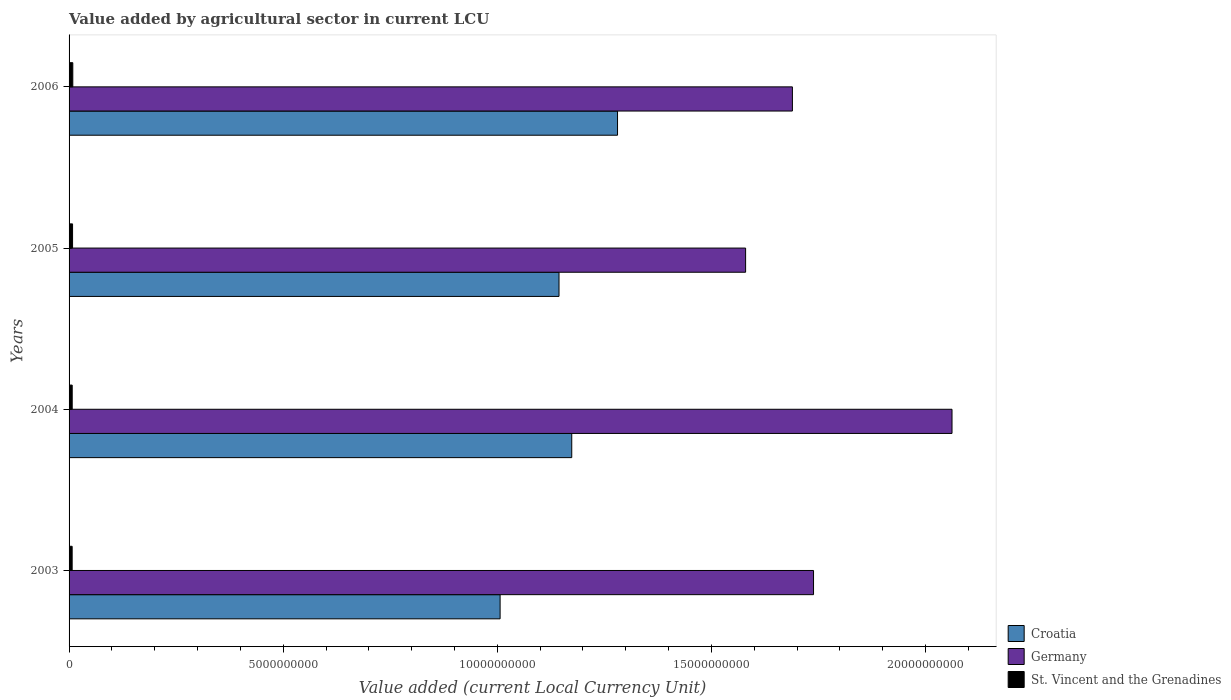How many different coloured bars are there?
Offer a terse response. 3. How many groups of bars are there?
Keep it short and to the point. 4. Are the number of bars on each tick of the Y-axis equal?
Offer a very short reply. Yes. How many bars are there on the 4th tick from the top?
Provide a succinct answer. 3. How many bars are there on the 2nd tick from the bottom?
Make the answer very short. 3. What is the label of the 4th group of bars from the top?
Offer a terse response. 2003. In how many cases, is the number of bars for a given year not equal to the number of legend labels?
Give a very brief answer. 0. What is the value added by agricultural sector in Croatia in 2004?
Keep it short and to the point. 1.17e+1. Across all years, what is the maximum value added by agricultural sector in Germany?
Offer a very short reply. 2.06e+1. Across all years, what is the minimum value added by agricultural sector in Croatia?
Make the answer very short. 1.01e+1. What is the total value added by agricultural sector in Croatia in the graph?
Offer a very short reply. 4.61e+1. What is the difference between the value added by agricultural sector in Croatia in 2003 and that in 2006?
Give a very brief answer. -2.74e+09. What is the difference between the value added by agricultural sector in St. Vincent and the Grenadines in 2004 and the value added by agricultural sector in Croatia in 2003?
Keep it short and to the point. -9.99e+09. What is the average value added by agricultural sector in Germany per year?
Your answer should be compact. 1.77e+1. In the year 2004, what is the difference between the value added by agricultural sector in Croatia and value added by agricultural sector in St. Vincent and the Grenadines?
Keep it short and to the point. 1.17e+1. What is the ratio of the value added by agricultural sector in Germany in 2003 to that in 2004?
Keep it short and to the point. 0.84. Is the value added by agricultural sector in Germany in 2003 less than that in 2005?
Offer a terse response. No. What is the difference between the highest and the second highest value added by agricultural sector in St. Vincent and the Grenadines?
Your answer should be compact. 5.52e+06. What is the difference between the highest and the lowest value added by agricultural sector in Croatia?
Offer a very short reply. 2.74e+09. What does the 3rd bar from the bottom in 2003 represents?
Provide a succinct answer. St. Vincent and the Grenadines. How many bars are there?
Your answer should be compact. 12. How many years are there in the graph?
Provide a short and direct response. 4. Does the graph contain any zero values?
Make the answer very short. No. Does the graph contain grids?
Your answer should be very brief. No. How are the legend labels stacked?
Provide a succinct answer. Vertical. What is the title of the graph?
Provide a succinct answer. Value added by agricultural sector in current LCU. What is the label or title of the X-axis?
Provide a succinct answer. Value added (current Local Currency Unit). What is the Value added (current Local Currency Unit) of Croatia in 2003?
Offer a very short reply. 1.01e+1. What is the Value added (current Local Currency Unit) of Germany in 2003?
Ensure brevity in your answer.  1.74e+1. What is the Value added (current Local Currency Unit) in St. Vincent and the Grenadines in 2003?
Ensure brevity in your answer.  7.19e+07. What is the Value added (current Local Currency Unit) in Croatia in 2004?
Make the answer very short. 1.17e+1. What is the Value added (current Local Currency Unit) of Germany in 2004?
Offer a terse response. 2.06e+1. What is the Value added (current Local Currency Unit) of St. Vincent and the Grenadines in 2004?
Your answer should be very brief. 7.33e+07. What is the Value added (current Local Currency Unit) of Croatia in 2005?
Provide a succinct answer. 1.14e+1. What is the Value added (current Local Currency Unit) in Germany in 2005?
Provide a short and direct response. 1.58e+1. What is the Value added (current Local Currency Unit) in St. Vincent and the Grenadines in 2005?
Provide a short and direct response. 8.14e+07. What is the Value added (current Local Currency Unit) in Croatia in 2006?
Keep it short and to the point. 1.28e+1. What is the Value added (current Local Currency Unit) of Germany in 2006?
Offer a terse response. 1.69e+1. What is the Value added (current Local Currency Unit) of St. Vincent and the Grenadines in 2006?
Provide a short and direct response. 8.69e+07. Across all years, what is the maximum Value added (current Local Currency Unit) of Croatia?
Make the answer very short. 1.28e+1. Across all years, what is the maximum Value added (current Local Currency Unit) of Germany?
Your answer should be very brief. 2.06e+1. Across all years, what is the maximum Value added (current Local Currency Unit) of St. Vincent and the Grenadines?
Provide a succinct answer. 8.69e+07. Across all years, what is the minimum Value added (current Local Currency Unit) in Croatia?
Your answer should be compact. 1.01e+1. Across all years, what is the minimum Value added (current Local Currency Unit) in Germany?
Provide a short and direct response. 1.58e+1. Across all years, what is the minimum Value added (current Local Currency Unit) in St. Vincent and the Grenadines?
Make the answer very short. 7.19e+07. What is the total Value added (current Local Currency Unit) in Croatia in the graph?
Offer a very short reply. 4.61e+1. What is the total Value added (current Local Currency Unit) in Germany in the graph?
Your response must be concise. 7.07e+1. What is the total Value added (current Local Currency Unit) in St. Vincent and the Grenadines in the graph?
Provide a short and direct response. 3.14e+08. What is the difference between the Value added (current Local Currency Unit) in Croatia in 2003 and that in 2004?
Keep it short and to the point. -1.67e+09. What is the difference between the Value added (current Local Currency Unit) in Germany in 2003 and that in 2004?
Ensure brevity in your answer.  -3.23e+09. What is the difference between the Value added (current Local Currency Unit) of St. Vincent and the Grenadines in 2003 and that in 2004?
Offer a terse response. -1.41e+06. What is the difference between the Value added (current Local Currency Unit) of Croatia in 2003 and that in 2005?
Give a very brief answer. -1.38e+09. What is the difference between the Value added (current Local Currency Unit) of Germany in 2003 and that in 2005?
Keep it short and to the point. 1.59e+09. What is the difference between the Value added (current Local Currency Unit) of St. Vincent and the Grenadines in 2003 and that in 2005?
Provide a short and direct response. -9.50e+06. What is the difference between the Value added (current Local Currency Unit) of Croatia in 2003 and that in 2006?
Provide a succinct answer. -2.74e+09. What is the difference between the Value added (current Local Currency Unit) in Germany in 2003 and that in 2006?
Provide a succinct answer. 4.93e+08. What is the difference between the Value added (current Local Currency Unit) of St. Vincent and the Grenadines in 2003 and that in 2006?
Your answer should be compact. -1.50e+07. What is the difference between the Value added (current Local Currency Unit) in Croatia in 2004 and that in 2005?
Your answer should be very brief. 2.97e+08. What is the difference between the Value added (current Local Currency Unit) of Germany in 2004 and that in 2005?
Keep it short and to the point. 4.82e+09. What is the difference between the Value added (current Local Currency Unit) of St. Vincent and the Grenadines in 2004 and that in 2005?
Your answer should be compact. -8.09e+06. What is the difference between the Value added (current Local Currency Unit) in Croatia in 2004 and that in 2006?
Provide a succinct answer. -1.07e+09. What is the difference between the Value added (current Local Currency Unit) of Germany in 2004 and that in 2006?
Ensure brevity in your answer.  3.73e+09. What is the difference between the Value added (current Local Currency Unit) in St. Vincent and the Grenadines in 2004 and that in 2006?
Provide a short and direct response. -1.36e+07. What is the difference between the Value added (current Local Currency Unit) in Croatia in 2005 and that in 2006?
Keep it short and to the point. -1.37e+09. What is the difference between the Value added (current Local Currency Unit) in Germany in 2005 and that in 2006?
Provide a short and direct response. -1.09e+09. What is the difference between the Value added (current Local Currency Unit) in St. Vincent and the Grenadines in 2005 and that in 2006?
Provide a short and direct response. -5.52e+06. What is the difference between the Value added (current Local Currency Unit) of Croatia in 2003 and the Value added (current Local Currency Unit) of Germany in 2004?
Your answer should be compact. -1.06e+1. What is the difference between the Value added (current Local Currency Unit) in Croatia in 2003 and the Value added (current Local Currency Unit) in St. Vincent and the Grenadines in 2004?
Make the answer very short. 9.99e+09. What is the difference between the Value added (current Local Currency Unit) of Germany in 2003 and the Value added (current Local Currency Unit) of St. Vincent and the Grenadines in 2004?
Keep it short and to the point. 1.73e+1. What is the difference between the Value added (current Local Currency Unit) in Croatia in 2003 and the Value added (current Local Currency Unit) in Germany in 2005?
Ensure brevity in your answer.  -5.73e+09. What is the difference between the Value added (current Local Currency Unit) in Croatia in 2003 and the Value added (current Local Currency Unit) in St. Vincent and the Grenadines in 2005?
Provide a short and direct response. 9.98e+09. What is the difference between the Value added (current Local Currency Unit) of Germany in 2003 and the Value added (current Local Currency Unit) of St. Vincent and the Grenadines in 2005?
Give a very brief answer. 1.73e+1. What is the difference between the Value added (current Local Currency Unit) in Croatia in 2003 and the Value added (current Local Currency Unit) in Germany in 2006?
Offer a very short reply. -6.83e+09. What is the difference between the Value added (current Local Currency Unit) of Croatia in 2003 and the Value added (current Local Currency Unit) of St. Vincent and the Grenadines in 2006?
Ensure brevity in your answer.  9.98e+09. What is the difference between the Value added (current Local Currency Unit) in Germany in 2003 and the Value added (current Local Currency Unit) in St. Vincent and the Grenadines in 2006?
Ensure brevity in your answer.  1.73e+1. What is the difference between the Value added (current Local Currency Unit) in Croatia in 2004 and the Value added (current Local Currency Unit) in Germany in 2005?
Provide a short and direct response. -4.06e+09. What is the difference between the Value added (current Local Currency Unit) in Croatia in 2004 and the Value added (current Local Currency Unit) in St. Vincent and the Grenadines in 2005?
Your answer should be very brief. 1.17e+1. What is the difference between the Value added (current Local Currency Unit) in Germany in 2004 and the Value added (current Local Currency Unit) in St. Vincent and the Grenadines in 2005?
Offer a very short reply. 2.05e+1. What is the difference between the Value added (current Local Currency Unit) in Croatia in 2004 and the Value added (current Local Currency Unit) in Germany in 2006?
Give a very brief answer. -5.15e+09. What is the difference between the Value added (current Local Currency Unit) in Croatia in 2004 and the Value added (current Local Currency Unit) in St. Vincent and the Grenadines in 2006?
Make the answer very short. 1.17e+1. What is the difference between the Value added (current Local Currency Unit) in Germany in 2004 and the Value added (current Local Currency Unit) in St. Vincent and the Grenadines in 2006?
Provide a short and direct response. 2.05e+1. What is the difference between the Value added (current Local Currency Unit) of Croatia in 2005 and the Value added (current Local Currency Unit) of Germany in 2006?
Provide a short and direct response. -5.45e+09. What is the difference between the Value added (current Local Currency Unit) of Croatia in 2005 and the Value added (current Local Currency Unit) of St. Vincent and the Grenadines in 2006?
Give a very brief answer. 1.14e+1. What is the difference between the Value added (current Local Currency Unit) of Germany in 2005 and the Value added (current Local Currency Unit) of St. Vincent and the Grenadines in 2006?
Make the answer very short. 1.57e+1. What is the average Value added (current Local Currency Unit) of Croatia per year?
Offer a terse response. 1.15e+1. What is the average Value added (current Local Currency Unit) of Germany per year?
Ensure brevity in your answer.  1.77e+1. What is the average Value added (current Local Currency Unit) in St. Vincent and the Grenadines per year?
Provide a succinct answer. 7.84e+07. In the year 2003, what is the difference between the Value added (current Local Currency Unit) in Croatia and Value added (current Local Currency Unit) in Germany?
Ensure brevity in your answer.  -7.32e+09. In the year 2003, what is the difference between the Value added (current Local Currency Unit) of Croatia and Value added (current Local Currency Unit) of St. Vincent and the Grenadines?
Provide a short and direct response. 9.99e+09. In the year 2003, what is the difference between the Value added (current Local Currency Unit) of Germany and Value added (current Local Currency Unit) of St. Vincent and the Grenadines?
Your response must be concise. 1.73e+1. In the year 2004, what is the difference between the Value added (current Local Currency Unit) in Croatia and Value added (current Local Currency Unit) in Germany?
Provide a short and direct response. -8.88e+09. In the year 2004, what is the difference between the Value added (current Local Currency Unit) of Croatia and Value added (current Local Currency Unit) of St. Vincent and the Grenadines?
Keep it short and to the point. 1.17e+1. In the year 2004, what is the difference between the Value added (current Local Currency Unit) in Germany and Value added (current Local Currency Unit) in St. Vincent and the Grenadines?
Your answer should be compact. 2.05e+1. In the year 2005, what is the difference between the Value added (current Local Currency Unit) in Croatia and Value added (current Local Currency Unit) in Germany?
Provide a succinct answer. -4.36e+09. In the year 2005, what is the difference between the Value added (current Local Currency Unit) of Croatia and Value added (current Local Currency Unit) of St. Vincent and the Grenadines?
Offer a very short reply. 1.14e+1. In the year 2005, what is the difference between the Value added (current Local Currency Unit) of Germany and Value added (current Local Currency Unit) of St. Vincent and the Grenadines?
Your response must be concise. 1.57e+1. In the year 2006, what is the difference between the Value added (current Local Currency Unit) of Croatia and Value added (current Local Currency Unit) of Germany?
Your answer should be very brief. -4.08e+09. In the year 2006, what is the difference between the Value added (current Local Currency Unit) of Croatia and Value added (current Local Currency Unit) of St. Vincent and the Grenadines?
Make the answer very short. 1.27e+1. In the year 2006, what is the difference between the Value added (current Local Currency Unit) in Germany and Value added (current Local Currency Unit) in St. Vincent and the Grenadines?
Keep it short and to the point. 1.68e+1. What is the ratio of the Value added (current Local Currency Unit) in Croatia in 2003 to that in 2004?
Your answer should be very brief. 0.86. What is the ratio of the Value added (current Local Currency Unit) of Germany in 2003 to that in 2004?
Make the answer very short. 0.84. What is the ratio of the Value added (current Local Currency Unit) in St. Vincent and the Grenadines in 2003 to that in 2004?
Offer a very short reply. 0.98. What is the ratio of the Value added (current Local Currency Unit) in Croatia in 2003 to that in 2005?
Your response must be concise. 0.88. What is the ratio of the Value added (current Local Currency Unit) in Germany in 2003 to that in 2005?
Give a very brief answer. 1.1. What is the ratio of the Value added (current Local Currency Unit) of St. Vincent and the Grenadines in 2003 to that in 2005?
Your answer should be very brief. 0.88. What is the ratio of the Value added (current Local Currency Unit) of Croatia in 2003 to that in 2006?
Give a very brief answer. 0.79. What is the ratio of the Value added (current Local Currency Unit) in Germany in 2003 to that in 2006?
Provide a succinct answer. 1.03. What is the ratio of the Value added (current Local Currency Unit) of St. Vincent and the Grenadines in 2003 to that in 2006?
Offer a very short reply. 0.83. What is the ratio of the Value added (current Local Currency Unit) in Croatia in 2004 to that in 2005?
Your response must be concise. 1.03. What is the ratio of the Value added (current Local Currency Unit) of Germany in 2004 to that in 2005?
Offer a terse response. 1.31. What is the ratio of the Value added (current Local Currency Unit) in St. Vincent and the Grenadines in 2004 to that in 2005?
Offer a terse response. 0.9. What is the ratio of the Value added (current Local Currency Unit) in Croatia in 2004 to that in 2006?
Give a very brief answer. 0.92. What is the ratio of the Value added (current Local Currency Unit) of Germany in 2004 to that in 2006?
Ensure brevity in your answer.  1.22. What is the ratio of the Value added (current Local Currency Unit) in St. Vincent and the Grenadines in 2004 to that in 2006?
Provide a short and direct response. 0.84. What is the ratio of the Value added (current Local Currency Unit) in Croatia in 2005 to that in 2006?
Ensure brevity in your answer.  0.89. What is the ratio of the Value added (current Local Currency Unit) in Germany in 2005 to that in 2006?
Your response must be concise. 0.94. What is the ratio of the Value added (current Local Currency Unit) in St. Vincent and the Grenadines in 2005 to that in 2006?
Ensure brevity in your answer.  0.94. What is the difference between the highest and the second highest Value added (current Local Currency Unit) of Croatia?
Make the answer very short. 1.07e+09. What is the difference between the highest and the second highest Value added (current Local Currency Unit) in Germany?
Provide a short and direct response. 3.23e+09. What is the difference between the highest and the second highest Value added (current Local Currency Unit) of St. Vincent and the Grenadines?
Make the answer very short. 5.52e+06. What is the difference between the highest and the lowest Value added (current Local Currency Unit) of Croatia?
Offer a terse response. 2.74e+09. What is the difference between the highest and the lowest Value added (current Local Currency Unit) in Germany?
Provide a succinct answer. 4.82e+09. What is the difference between the highest and the lowest Value added (current Local Currency Unit) in St. Vincent and the Grenadines?
Offer a very short reply. 1.50e+07. 